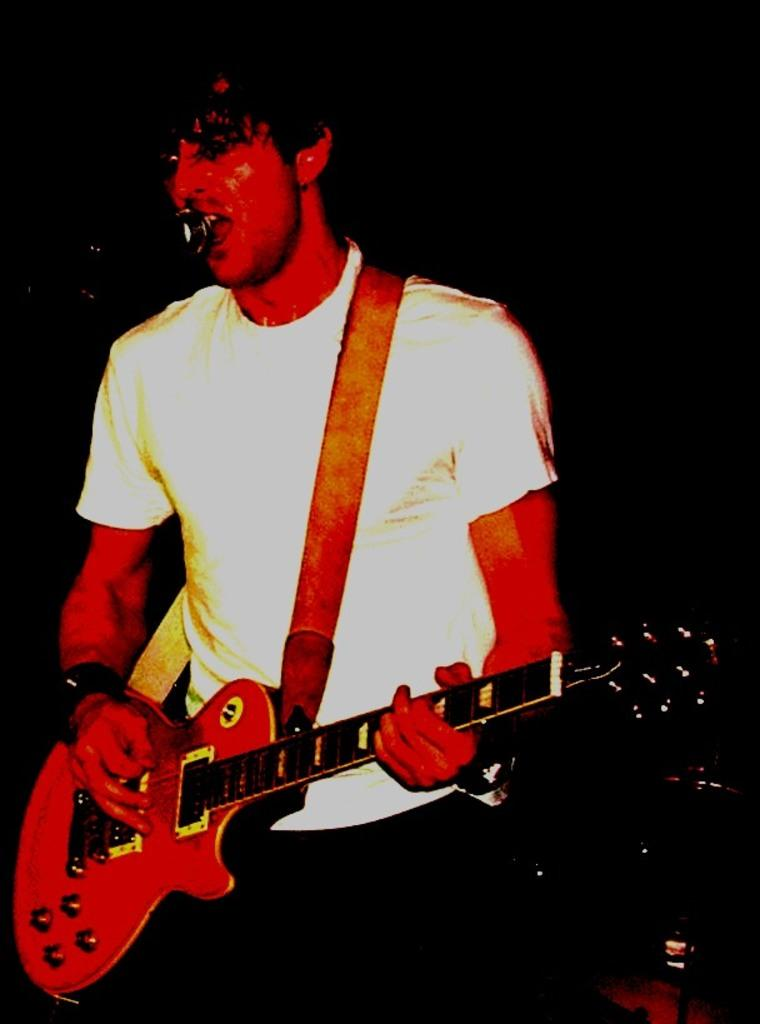What is the main subject of the image? The main subject of the image is a man. What is the man doing in the image? The man is standing and singing on a microphone. What instrument is the man holding in the image? The man is holding a guitar in the image. Is the man playing the guitar in the image? Yes, the man is playing the guitar in the image. What type of fowl can be seen flying in the image? There is no fowl present in the image; it features a man singing and playing the guitar. How many fingers is the man using to play the guitar in the image? The image does not show the man's fingers, so it cannot be determined how many fingers he is using to play the guitar. 